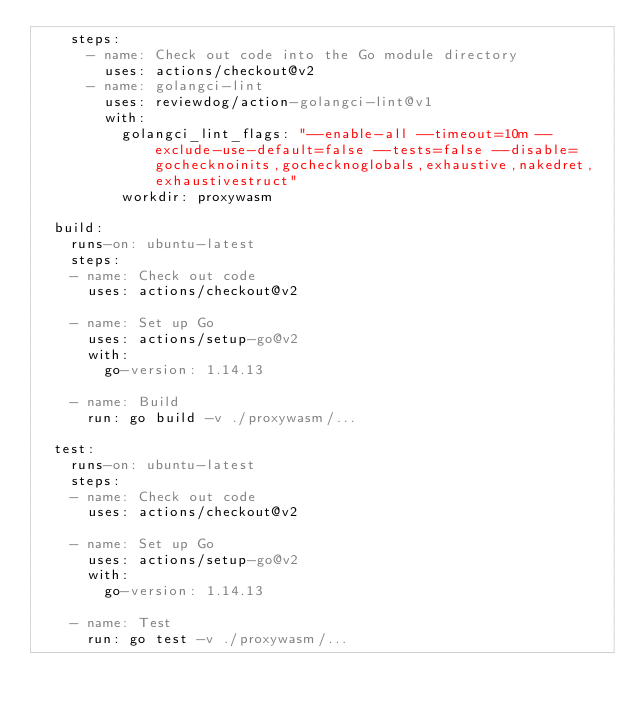Convert code to text. <code><loc_0><loc_0><loc_500><loc_500><_YAML_>    steps:
      - name: Check out code into the Go module directory
        uses: actions/checkout@v2
      - name: golangci-lint
        uses: reviewdog/action-golangci-lint@v1
        with:
          golangci_lint_flags: "--enable-all --timeout=10m --exclude-use-default=false --tests=false --disable=gochecknoinits,gochecknoglobals,exhaustive,nakedret,exhaustivestruct"
          workdir: proxywasm

  build:
    runs-on: ubuntu-latest
    steps:
    - name: Check out code
      uses: actions/checkout@v2

    - name: Set up Go
      uses: actions/setup-go@v2
      with:
        go-version: 1.14.13

    - name: Build
      run: go build -v ./proxywasm/...

  test:
    runs-on: ubuntu-latest
    steps:
    - name: Check out code
      uses: actions/checkout@v2

    - name: Set up Go
      uses: actions/setup-go@v2
      with:
        go-version: 1.14.13

    - name: Test
      run: go test -v ./proxywasm/...
</code> 